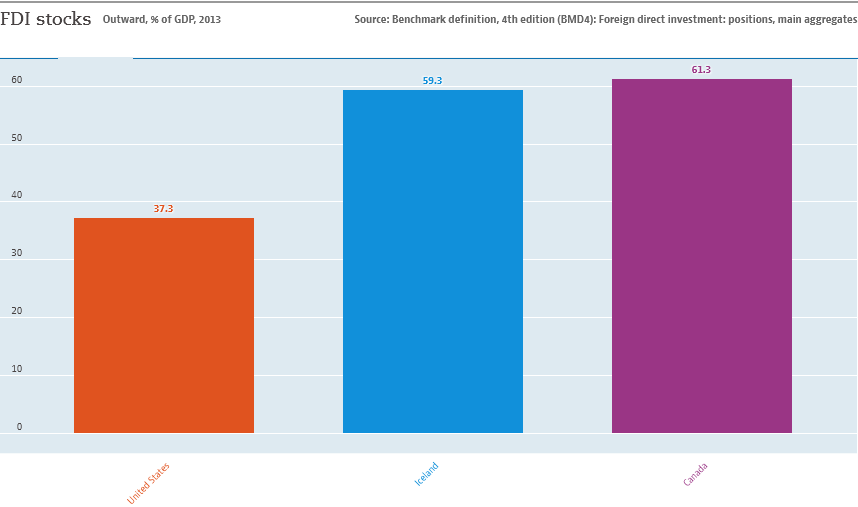What is the value of the highest bar?
 61.3 